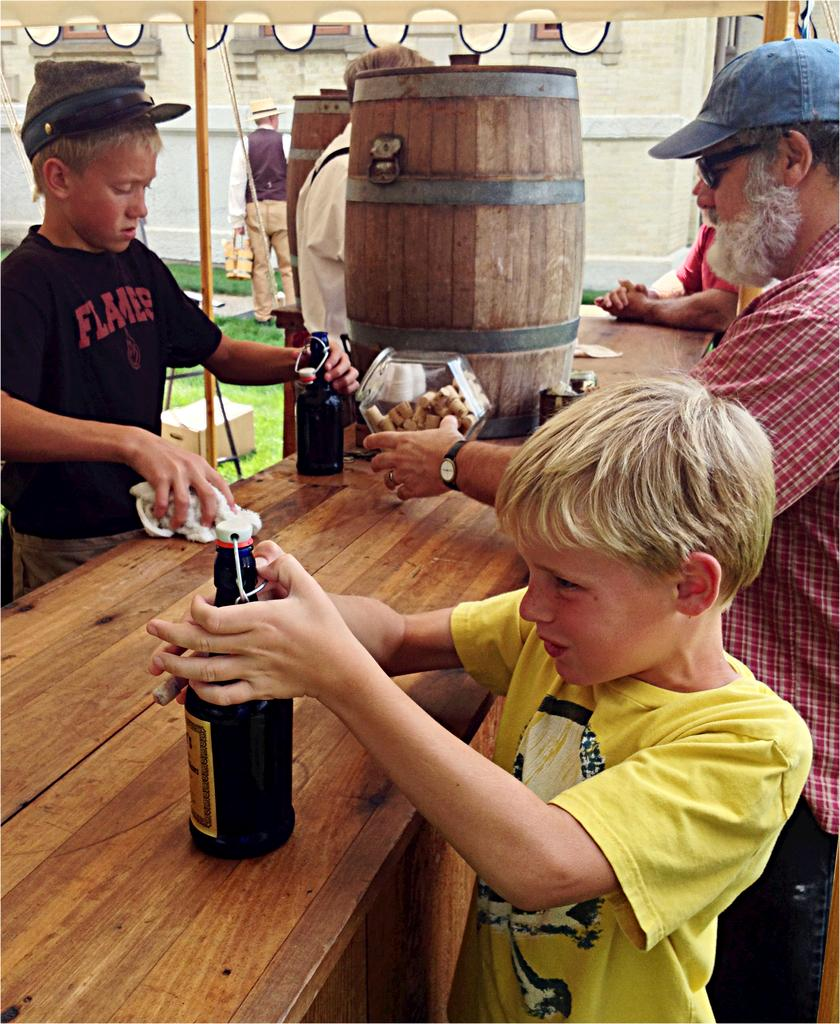What is the child in the image holding? The child is holding a bottle. Where is the bottle placed in relation to the child? The bottle is placed on a table. What can be seen in the background of the image? There are people standing in the background of the image, and there is a wooden can. Can you describe the wooden can in the background? The wooden can is a large container, likely used for storage or display. How many quarters does the child have in their pocket in the image? There is no information about quarters or the child's pocket in the image, so we cannot determine the number of quarters. 